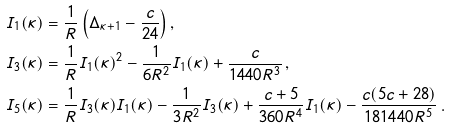<formula> <loc_0><loc_0><loc_500><loc_500>& I _ { 1 } ( \kappa ) = \frac { 1 } { R } \left ( \Delta _ { \kappa + 1 } - \frac { c } { 2 4 } \right ) , \\ & I _ { 3 } ( \kappa ) = \frac { 1 } { R } I _ { 1 } ( \kappa ) ^ { 2 } - \frac { 1 } { 6 R ^ { 2 } } I _ { 1 } ( \kappa ) + \frac { c } { 1 4 4 0 R ^ { 3 } } \, , \\ & I _ { 5 } ( \kappa ) = \frac { 1 } { R } I _ { 3 } ( \kappa ) I _ { 1 } ( \kappa ) - \frac { 1 } { 3 R ^ { 2 } } I _ { 3 } ( \kappa ) + \frac { c + 5 } { 3 6 0 R ^ { 4 } } I _ { 1 } ( \kappa ) - \frac { c ( 5 c + 2 8 ) } { 1 8 1 4 4 0 R ^ { 5 } } \, .</formula> 